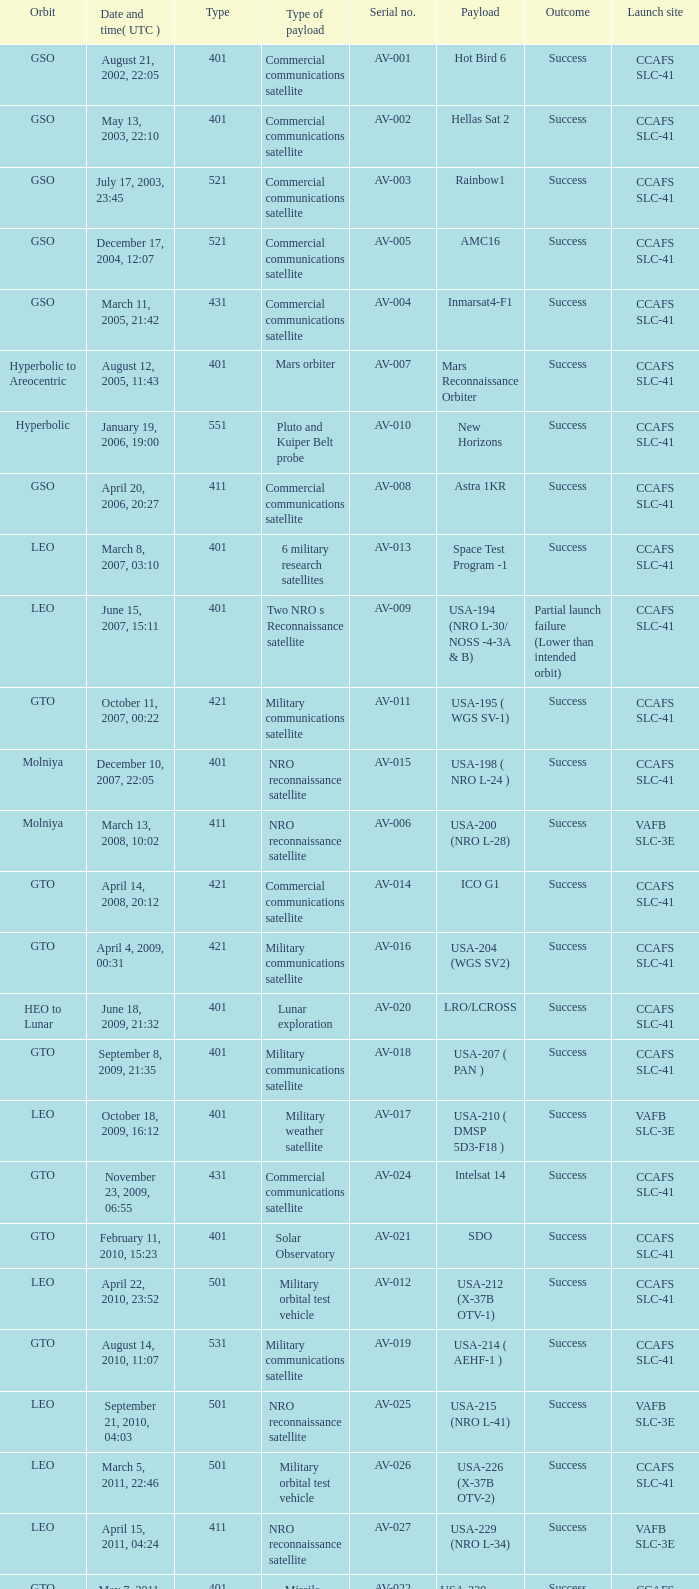For the payload of Van Allen Belts Exploration what's the serial number? AV-032. 